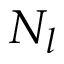<formula> <loc_0><loc_0><loc_500><loc_500>N _ { l }</formula> 